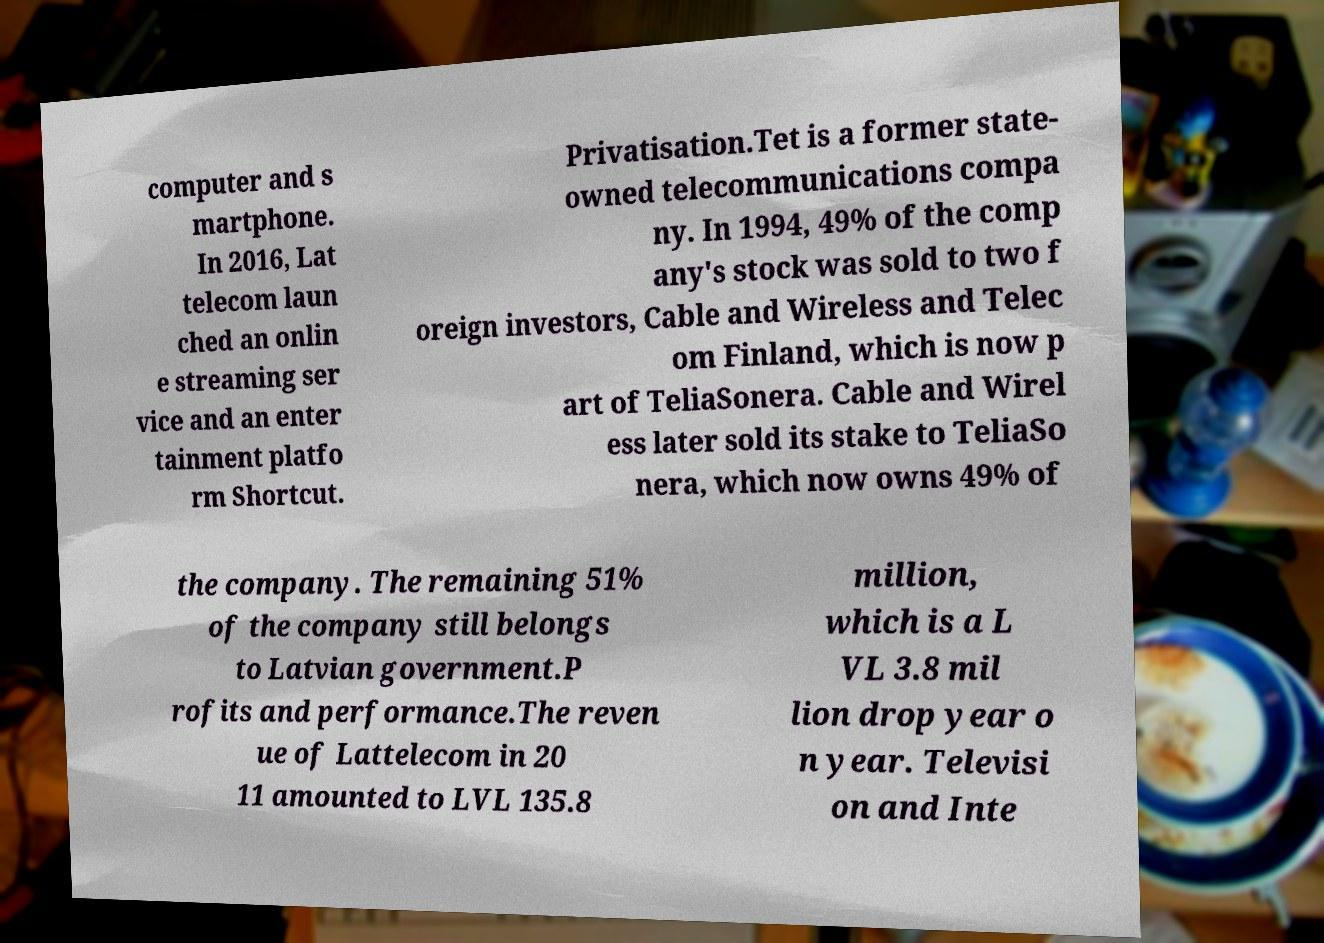For documentation purposes, I need the text within this image transcribed. Could you provide that? computer and s martphone. In 2016, Lat telecom laun ched an onlin e streaming ser vice and an enter tainment platfo rm Shortcut. Privatisation.Tet is a former state- owned telecommunications compa ny. In 1994, 49% of the comp any's stock was sold to two f oreign investors, Cable and Wireless and Telec om Finland, which is now p art of TeliaSonera. Cable and Wirel ess later sold its stake to TeliaSo nera, which now owns 49% of the company. The remaining 51% of the company still belongs to Latvian government.P rofits and performance.The reven ue of Lattelecom in 20 11 amounted to LVL 135.8 million, which is a L VL 3.8 mil lion drop year o n year. Televisi on and Inte 